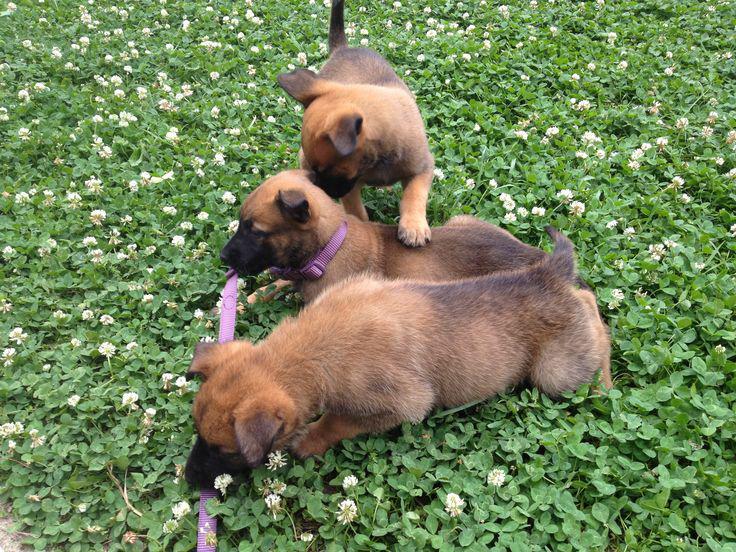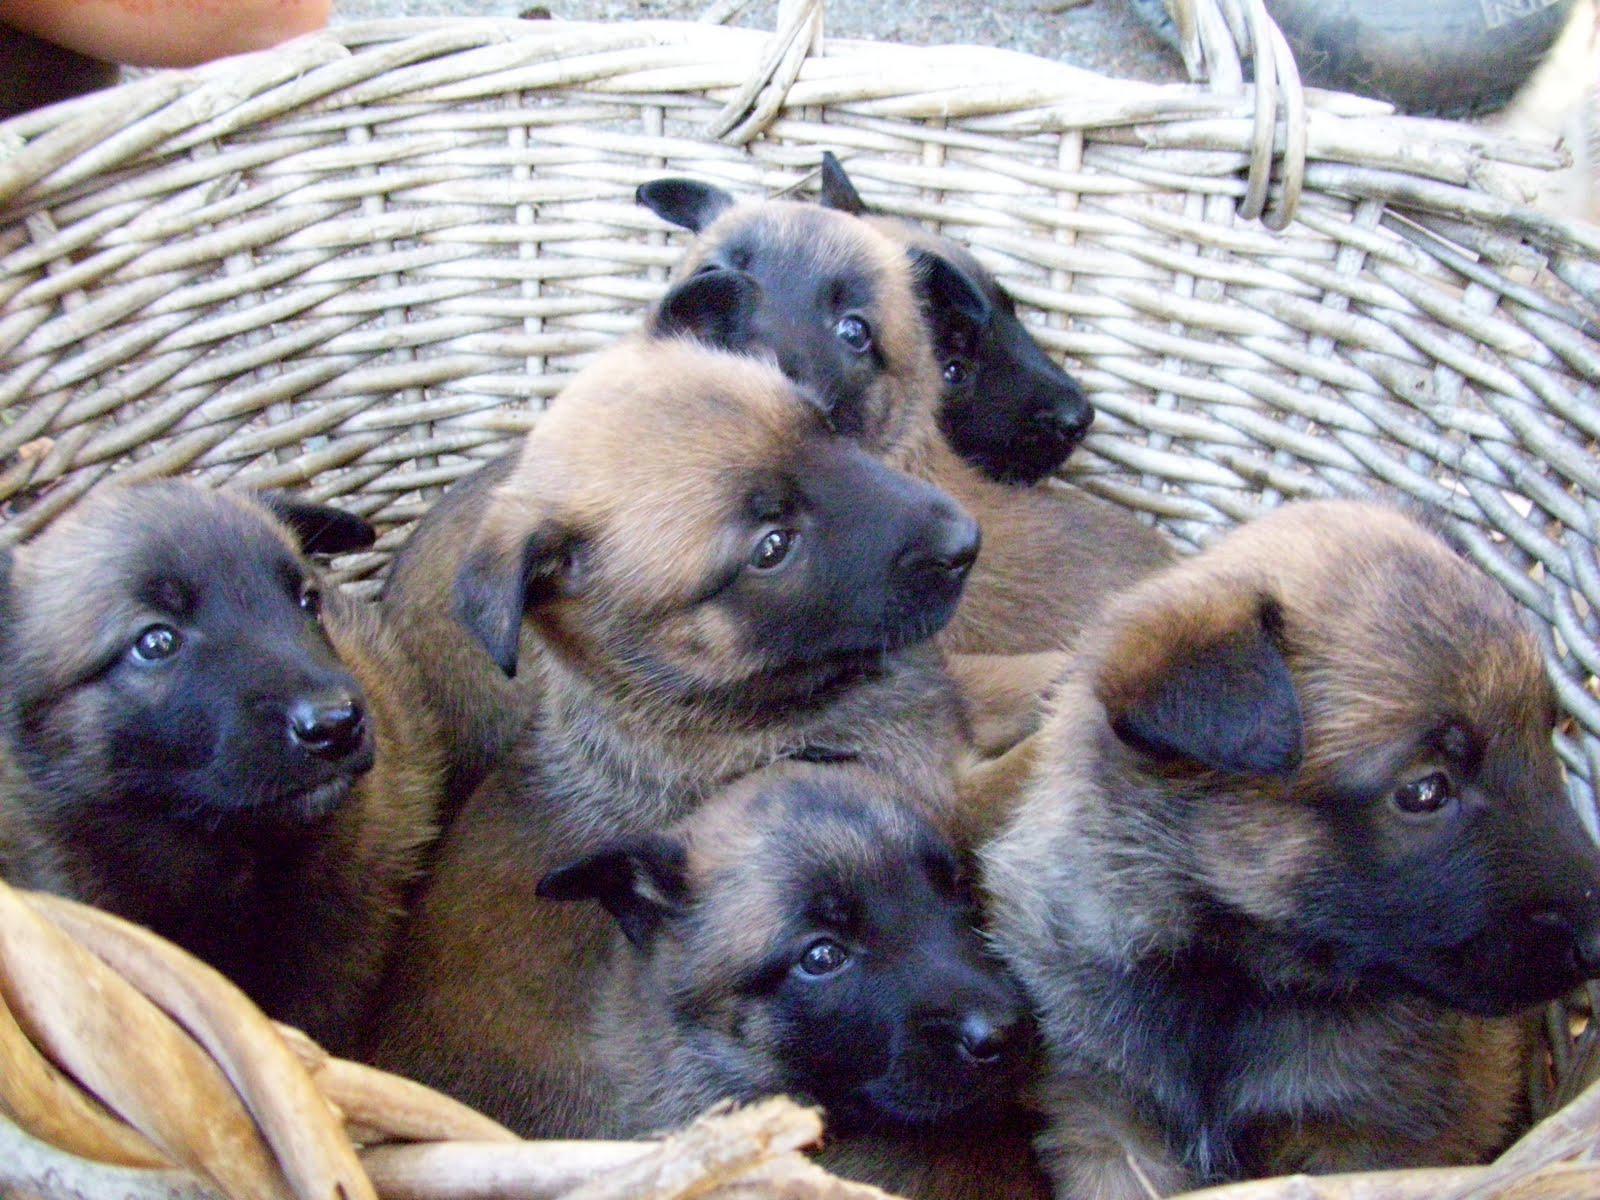The first image is the image on the left, the second image is the image on the right. For the images shown, is this caption "A person is holding at least one dog in one image." true? Answer yes or no. No. The first image is the image on the left, the second image is the image on the right. Analyze the images presented: Is the assertion "A person is holding at least one of the dogs in one of the images." valid? Answer yes or no. No. 